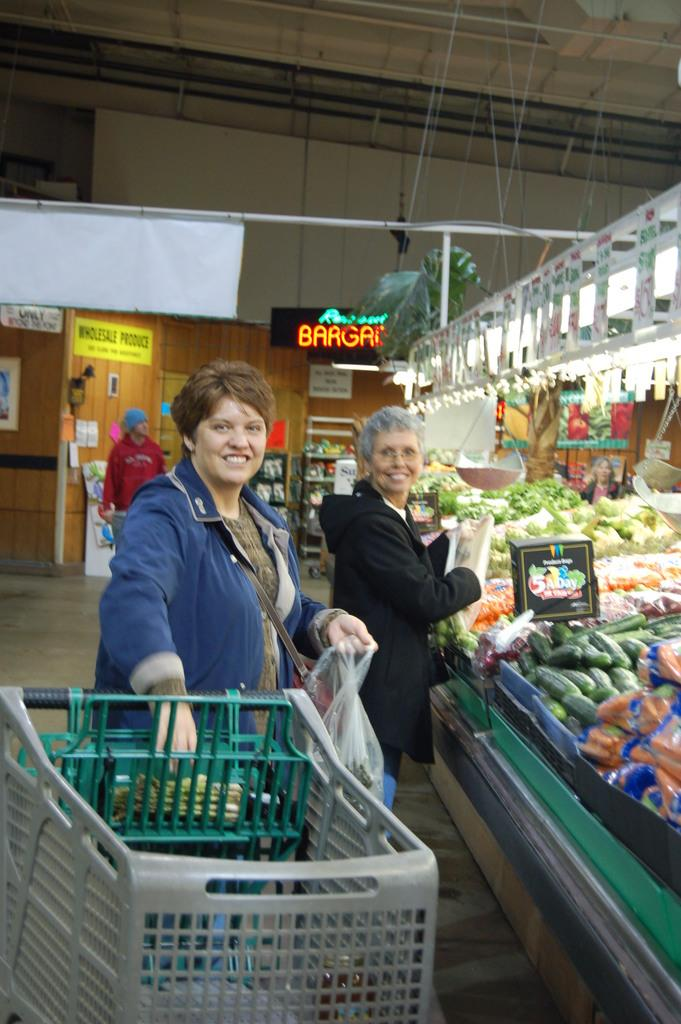<image>
Create a compact narrative representing the image presented. Two women shopping in a store in front of a sign saying 5 A Day. 